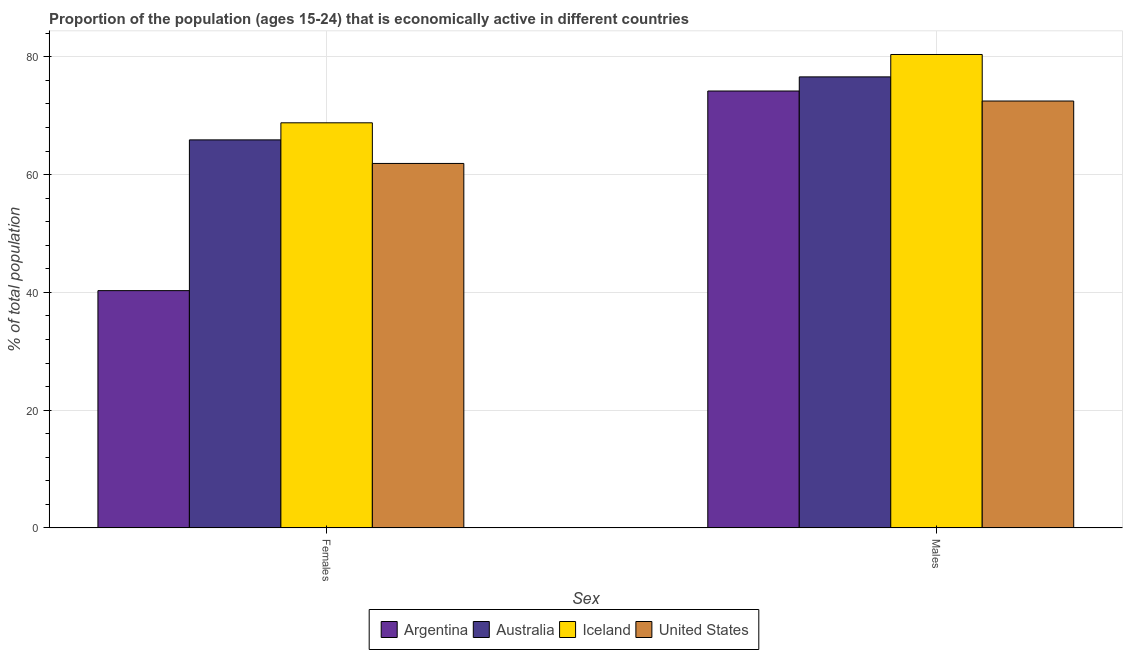How many different coloured bars are there?
Offer a very short reply. 4. How many groups of bars are there?
Your answer should be compact. 2. Are the number of bars per tick equal to the number of legend labels?
Offer a very short reply. Yes. How many bars are there on the 2nd tick from the left?
Provide a succinct answer. 4. How many bars are there on the 1st tick from the right?
Provide a succinct answer. 4. What is the label of the 1st group of bars from the left?
Your answer should be very brief. Females. What is the percentage of economically active male population in Argentina?
Keep it short and to the point. 74.2. Across all countries, what is the maximum percentage of economically active female population?
Keep it short and to the point. 68.8. Across all countries, what is the minimum percentage of economically active female population?
Your answer should be compact. 40.3. In which country was the percentage of economically active male population minimum?
Make the answer very short. United States. What is the total percentage of economically active female population in the graph?
Ensure brevity in your answer.  236.9. What is the difference between the percentage of economically active female population in United States and that in Argentina?
Your answer should be very brief. 21.6. What is the difference between the percentage of economically active male population in Argentina and the percentage of economically active female population in Australia?
Ensure brevity in your answer.  8.3. What is the average percentage of economically active female population per country?
Ensure brevity in your answer.  59.23. What is the difference between the percentage of economically active female population and percentage of economically active male population in Iceland?
Make the answer very short. -11.6. What is the ratio of the percentage of economically active male population in Argentina to that in United States?
Offer a very short reply. 1.02. Is the percentage of economically active male population in Australia less than that in Iceland?
Your answer should be very brief. Yes. In how many countries, is the percentage of economically active male population greater than the average percentage of economically active male population taken over all countries?
Provide a succinct answer. 2. What does the 2nd bar from the left in Males represents?
Make the answer very short. Australia. Are all the bars in the graph horizontal?
Offer a very short reply. No. How many countries are there in the graph?
Keep it short and to the point. 4. What is the difference between two consecutive major ticks on the Y-axis?
Offer a terse response. 20. Are the values on the major ticks of Y-axis written in scientific E-notation?
Provide a succinct answer. No. What is the title of the graph?
Ensure brevity in your answer.  Proportion of the population (ages 15-24) that is economically active in different countries. Does "Iceland" appear as one of the legend labels in the graph?
Your answer should be compact. Yes. What is the label or title of the X-axis?
Provide a short and direct response. Sex. What is the label or title of the Y-axis?
Offer a very short reply. % of total population. What is the % of total population of Argentina in Females?
Offer a very short reply. 40.3. What is the % of total population of Australia in Females?
Your answer should be very brief. 65.9. What is the % of total population of Iceland in Females?
Make the answer very short. 68.8. What is the % of total population of United States in Females?
Offer a very short reply. 61.9. What is the % of total population in Argentina in Males?
Provide a short and direct response. 74.2. What is the % of total population of Australia in Males?
Provide a succinct answer. 76.6. What is the % of total population in Iceland in Males?
Offer a very short reply. 80.4. What is the % of total population in United States in Males?
Offer a very short reply. 72.5. Across all Sex, what is the maximum % of total population in Argentina?
Offer a very short reply. 74.2. Across all Sex, what is the maximum % of total population of Australia?
Make the answer very short. 76.6. Across all Sex, what is the maximum % of total population of Iceland?
Make the answer very short. 80.4. Across all Sex, what is the maximum % of total population in United States?
Provide a short and direct response. 72.5. Across all Sex, what is the minimum % of total population in Argentina?
Your response must be concise. 40.3. Across all Sex, what is the minimum % of total population in Australia?
Keep it short and to the point. 65.9. Across all Sex, what is the minimum % of total population of Iceland?
Offer a very short reply. 68.8. Across all Sex, what is the minimum % of total population of United States?
Offer a terse response. 61.9. What is the total % of total population of Argentina in the graph?
Offer a terse response. 114.5. What is the total % of total population of Australia in the graph?
Offer a terse response. 142.5. What is the total % of total population of Iceland in the graph?
Your answer should be very brief. 149.2. What is the total % of total population of United States in the graph?
Offer a very short reply. 134.4. What is the difference between the % of total population of Argentina in Females and that in Males?
Give a very brief answer. -33.9. What is the difference between the % of total population in Australia in Females and that in Males?
Provide a short and direct response. -10.7. What is the difference between the % of total population of United States in Females and that in Males?
Keep it short and to the point. -10.6. What is the difference between the % of total population in Argentina in Females and the % of total population in Australia in Males?
Your response must be concise. -36.3. What is the difference between the % of total population in Argentina in Females and the % of total population in Iceland in Males?
Keep it short and to the point. -40.1. What is the difference between the % of total population of Argentina in Females and the % of total population of United States in Males?
Offer a very short reply. -32.2. What is the difference between the % of total population in Australia in Females and the % of total population in United States in Males?
Provide a succinct answer. -6.6. What is the difference between the % of total population in Iceland in Females and the % of total population in United States in Males?
Your response must be concise. -3.7. What is the average % of total population of Argentina per Sex?
Your response must be concise. 57.25. What is the average % of total population of Australia per Sex?
Keep it short and to the point. 71.25. What is the average % of total population in Iceland per Sex?
Ensure brevity in your answer.  74.6. What is the average % of total population of United States per Sex?
Provide a short and direct response. 67.2. What is the difference between the % of total population of Argentina and % of total population of Australia in Females?
Provide a succinct answer. -25.6. What is the difference between the % of total population in Argentina and % of total population in Iceland in Females?
Your answer should be very brief. -28.5. What is the difference between the % of total population in Argentina and % of total population in United States in Females?
Your answer should be very brief. -21.6. What is the difference between the % of total population of Iceland and % of total population of United States in Females?
Your answer should be very brief. 6.9. What is the difference between the % of total population in Argentina and % of total population in Australia in Males?
Provide a short and direct response. -2.4. What is the difference between the % of total population of Australia and % of total population of Iceland in Males?
Give a very brief answer. -3.8. What is the difference between the % of total population in Australia and % of total population in United States in Males?
Your answer should be very brief. 4.1. What is the ratio of the % of total population in Argentina in Females to that in Males?
Offer a very short reply. 0.54. What is the ratio of the % of total population in Australia in Females to that in Males?
Offer a terse response. 0.86. What is the ratio of the % of total population in Iceland in Females to that in Males?
Offer a very short reply. 0.86. What is the ratio of the % of total population in United States in Females to that in Males?
Offer a terse response. 0.85. What is the difference between the highest and the second highest % of total population in Argentina?
Make the answer very short. 33.9. What is the difference between the highest and the second highest % of total population in Australia?
Offer a very short reply. 10.7. What is the difference between the highest and the second highest % of total population in Iceland?
Make the answer very short. 11.6. What is the difference between the highest and the second highest % of total population in United States?
Make the answer very short. 10.6. What is the difference between the highest and the lowest % of total population in Argentina?
Ensure brevity in your answer.  33.9. What is the difference between the highest and the lowest % of total population of Australia?
Keep it short and to the point. 10.7. What is the difference between the highest and the lowest % of total population of Iceland?
Ensure brevity in your answer.  11.6. What is the difference between the highest and the lowest % of total population of United States?
Give a very brief answer. 10.6. 